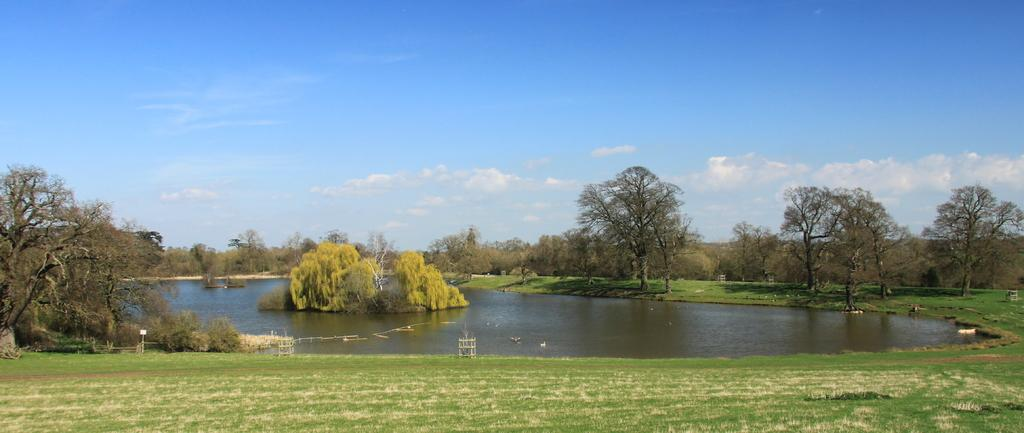What type of vegetation can be seen in the image? There are trees in the image. What else can be seen besides trees? There is water visible in the image. What is at the bottom of the image? There is grass at the bottom of the image. What is visible in the background of the image? The sky is visible in the background of the image. How many mountains are visible in the image? There are no mountains visible in the image. What does the dad say about the image? There is no mention of a dad or any person's opinion in the image or the provided facts. 